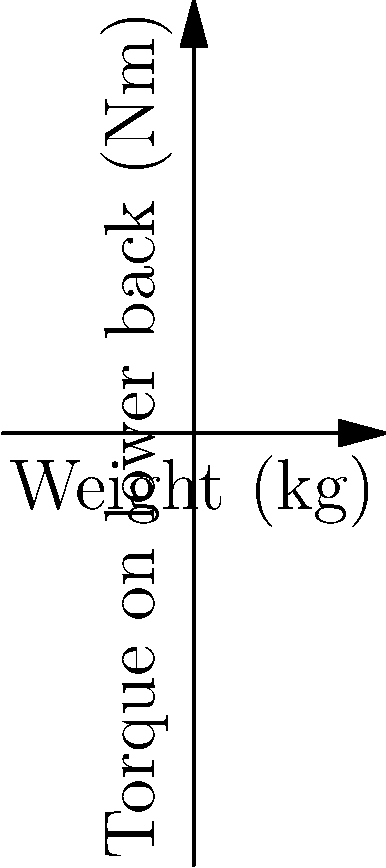The graph shows the relationship between the weight of emergency response equipment and the torque exerted on a responder's lower back. Based on the data, what is the approximate reduction in lower back torque when switching from traditional equipment weighing 20 kg to ergonomic equipment of the same weight? To solve this problem, we need to follow these steps:

1. Identify the torque for traditional equipment at 20 kg:
   From the graph, we can see that at 20 kg, the torque is approximately 100 Nm.

2. Estimate the torque for ergonomic equipment at 20 kg:
   The arrow indicates that ergonomic equipment produces less torque. At 20 kg, it appears to be around 67 Nm.

3. Calculate the difference in torque:
   $$\text{Torque difference} = 100 \text{ Nm} - 67 \text{ Nm} = 33 \text{ Nm}$$

4. Calculate the percentage reduction:
   $$\text{Percentage reduction} = \frac{\text{Torque difference}}{\text{Original torque}} \times 100\%$$
   $$= \frac{33 \text{ Nm}}{100 \text{ Nm}} \times 100\% = 33\%$$

Therefore, the approximate reduction in lower back torque when switching from traditional to ergonomic equipment weighing 20 kg is 33%.
Answer: 33% 